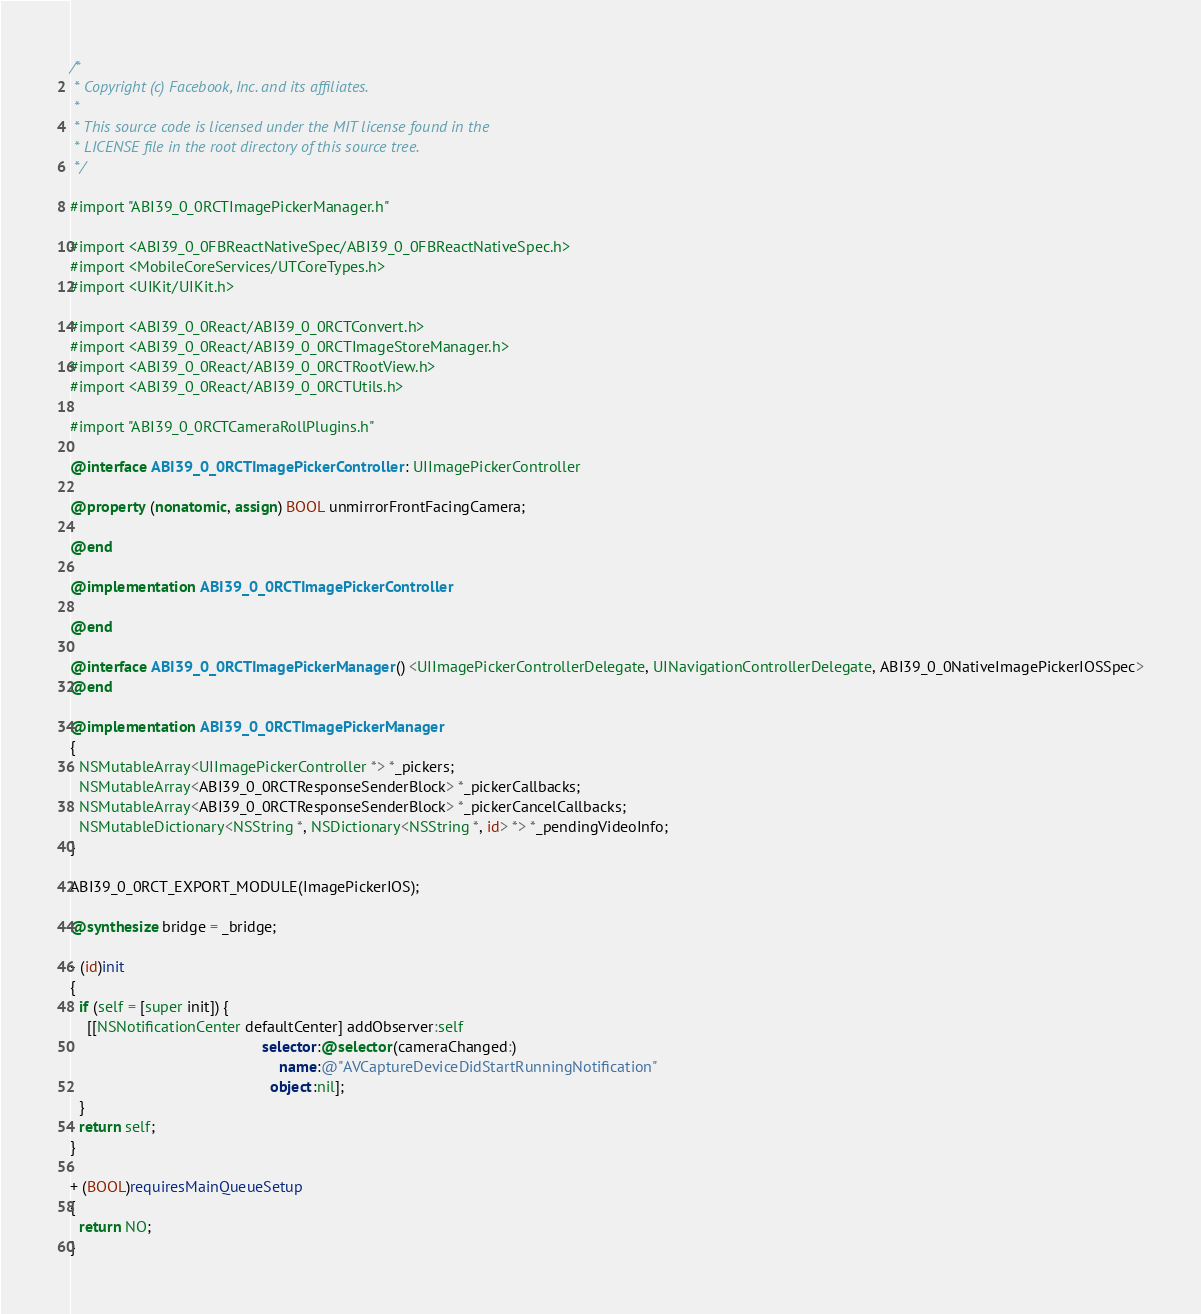<code> <loc_0><loc_0><loc_500><loc_500><_ObjectiveC_>/*
 * Copyright (c) Facebook, Inc. and its affiliates.
 *
 * This source code is licensed under the MIT license found in the
 * LICENSE file in the root directory of this source tree.
 */

#import "ABI39_0_0RCTImagePickerManager.h"

#import <ABI39_0_0FBReactNativeSpec/ABI39_0_0FBReactNativeSpec.h>
#import <MobileCoreServices/UTCoreTypes.h>
#import <UIKit/UIKit.h>

#import <ABI39_0_0React/ABI39_0_0RCTConvert.h>
#import <ABI39_0_0React/ABI39_0_0RCTImageStoreManager.h>
#import <ABI39_0_0React/ABI39_0_0RCTRootView.h>
#import <ABI39_0_0React/ABI39_0_0RCTUtils.h>

#import "ABI39_0_0RCTCameraRollPlugins.h"

@interface ABI39_0_0RCTImagePickerController : UIImagePickerController

@property (nonatomic, assign) BOOL unmirrorFrontFacingCamera;

@end

@implementation ABI39_0_0RCTImagePickerController

@end

@interface ABI39_0_0RCTImagePickerManager () <UIImagePickerControllerDelegate, UINavigationControllerDelegate, ABI39_0_0NativeImagePickerIOSSpec>
@end

@implementation ABI39_0_0RCTImagePickerManager
{
  NSMutableArray<UIImagePickerController *> *_pickers;
  NSMutableArray<ABI39_0_0RCTResponseSenderBlock> *_pickerCallbacks;
  NSMutableArray<ABI39_0_0RCTResponseSenderBlock> *_pickerCancelCallbacks;
  NSMutableDictionary<NSString *, NSDictionary<NSString *, id> *> *_pendingVideoInfo;
}

ABI39_0_0RCT_EXPORT_MODULE(ImagePickerIOS);

@synthesize bridge = _bridge;

- (id)init
{
  if (self = [super init]) {
    [[NSNotificationCenter defaultCenter] addObserver:self
                                             selector:@selector(cameraChanged:)
                                                 name:@"AVCaptureDeviceDidStartRunningNotification"
                                               object:nil];
  }
  return self;
}

+ (BOOL)requiresMainQueueSetup
{
  return NO;
}
</code> 